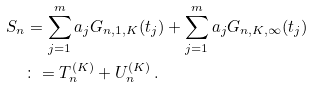Convert formula to latex. <formula><loc_0><loc_0><loc_500><loc_500>S _ { n } & = \sum _ { j = 1 } ^ { m } a _ { j } G _ { n , 1 , K } ( t _ { j } ) + \sum _ { j = 1 } ^ { m } a _ { j } G _ { n , K , \infty } ( t _ { j } ) \\ & \colon = T _ { n } ^ { ( K ) } + U _ { n } ^ { ( K ) } \, .</formula> 